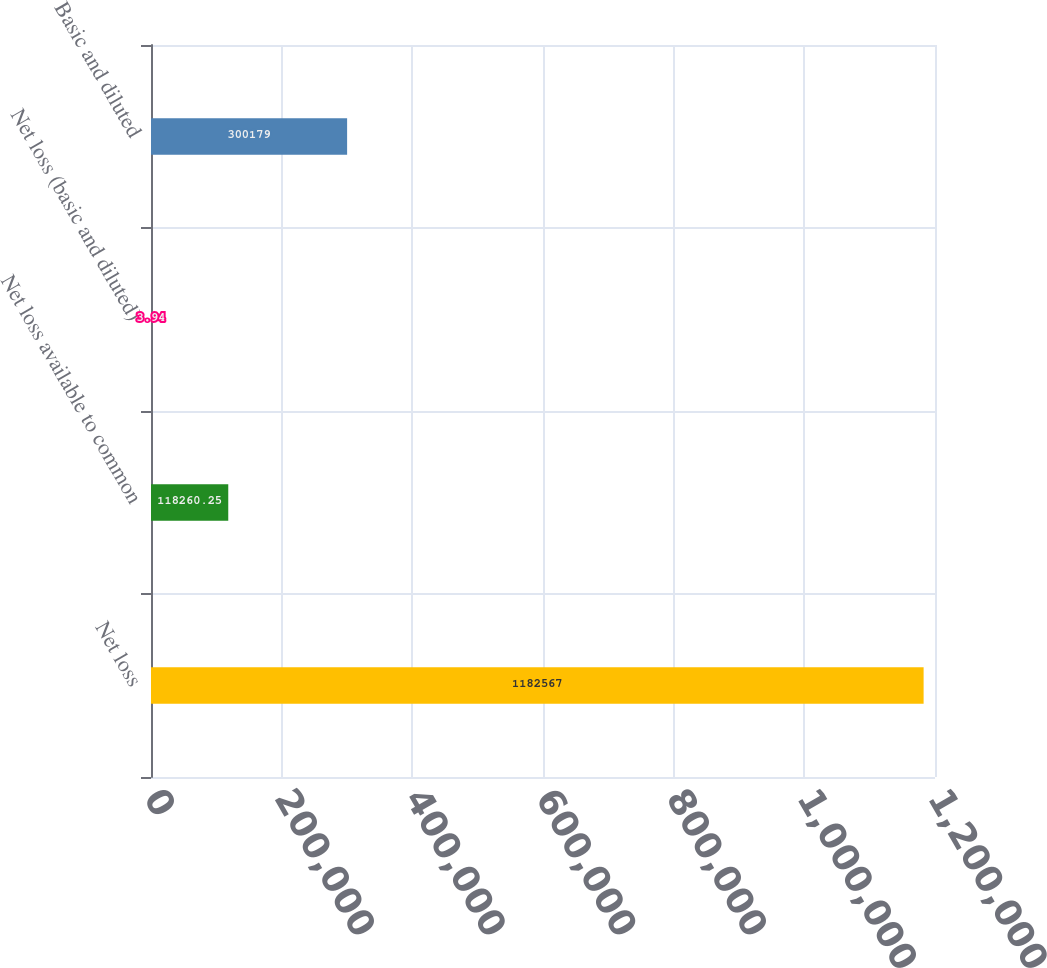<chart> <loc_0><loc_0><loc_500><loc_500><bar_chart><fcel>Net loss<fcel>Net loss available to common<fcel>Net loss (basic and diluted)<fcel>Basic and diluted<nl><fcel>1.18257e+06<fcel>118260<fcel>3.94<fcel>300179<nl></chart> 